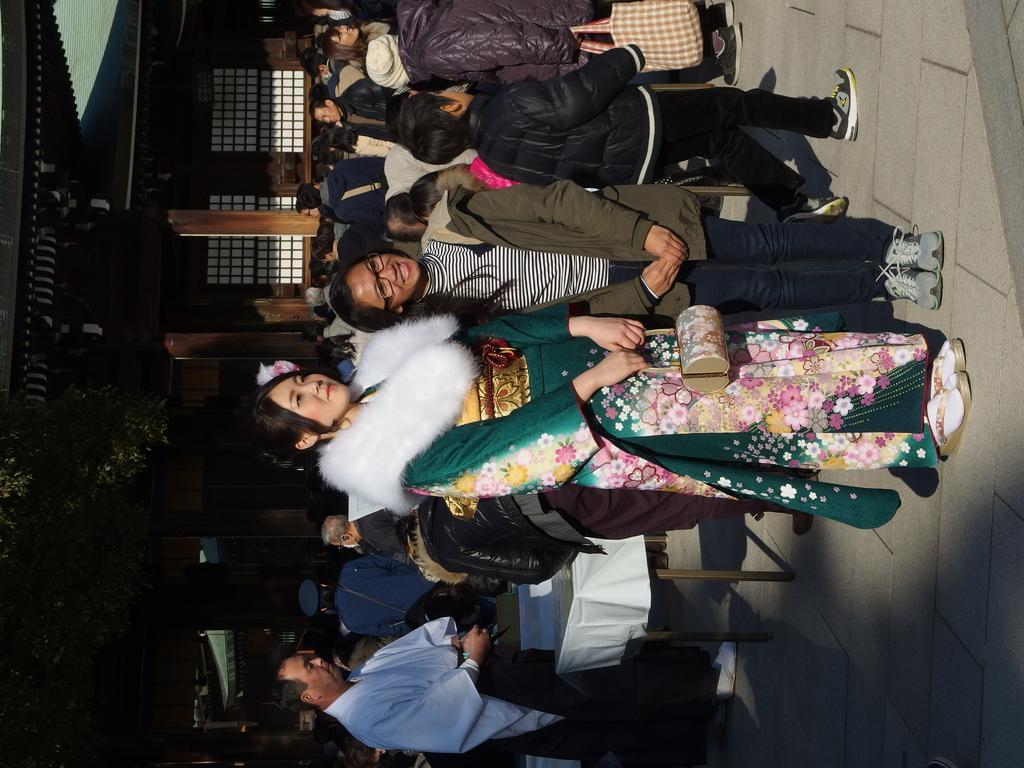How would you summarize this image in a sentence or two? This picture is clicked outside. In the foreground we can see the group of people seems to be standing on the ground and we can see a woman wearing a costume, holding a bag and standing on the ground and we can see the table and some other objects. In the background we can see the tree and the house and we can see the pillars and some other objects. 